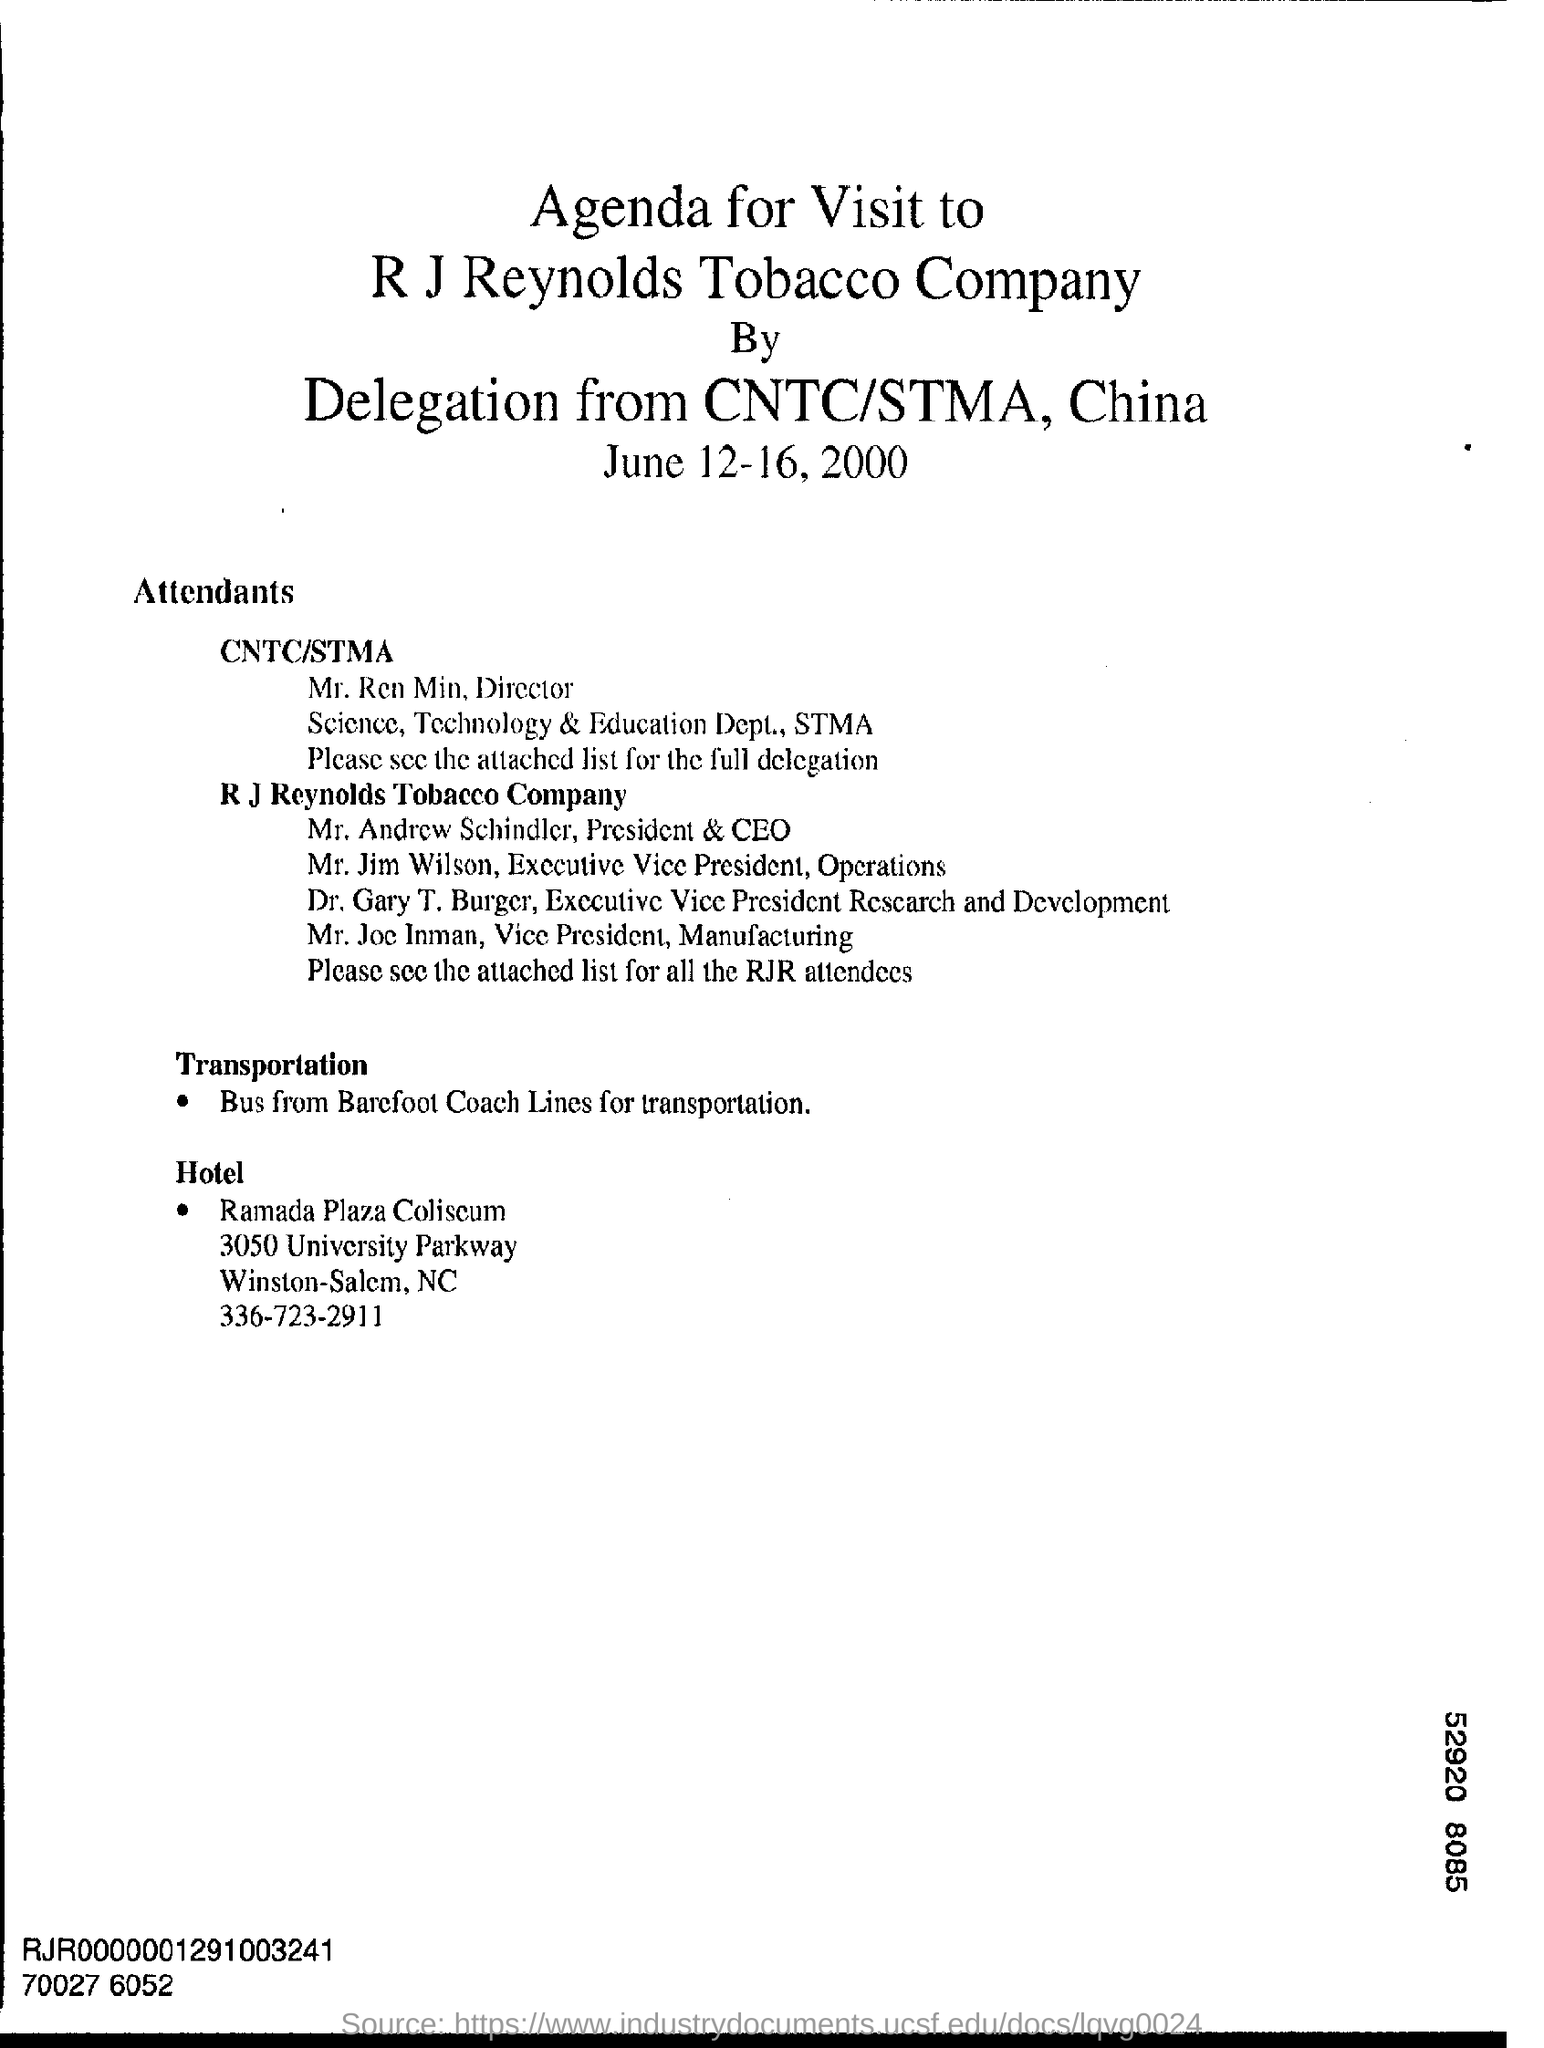In which state is ramada plaza coliseum at ?
Provide a short and direct response. NC. What is the name of the tobacco company?
Ensure brevity in your answer.  R J Reynolds Tobacco Company. What is the position of mr .andrew schindler ?
Give a very brief answer. President & CEO. Who is the vice president, manufacturing of r j reynolds tobacco company?
Your answer should be compact. Mr. Joe Inman. Where are delegation from ?
Keep it short and to the point. CNTC/STMA, China. 